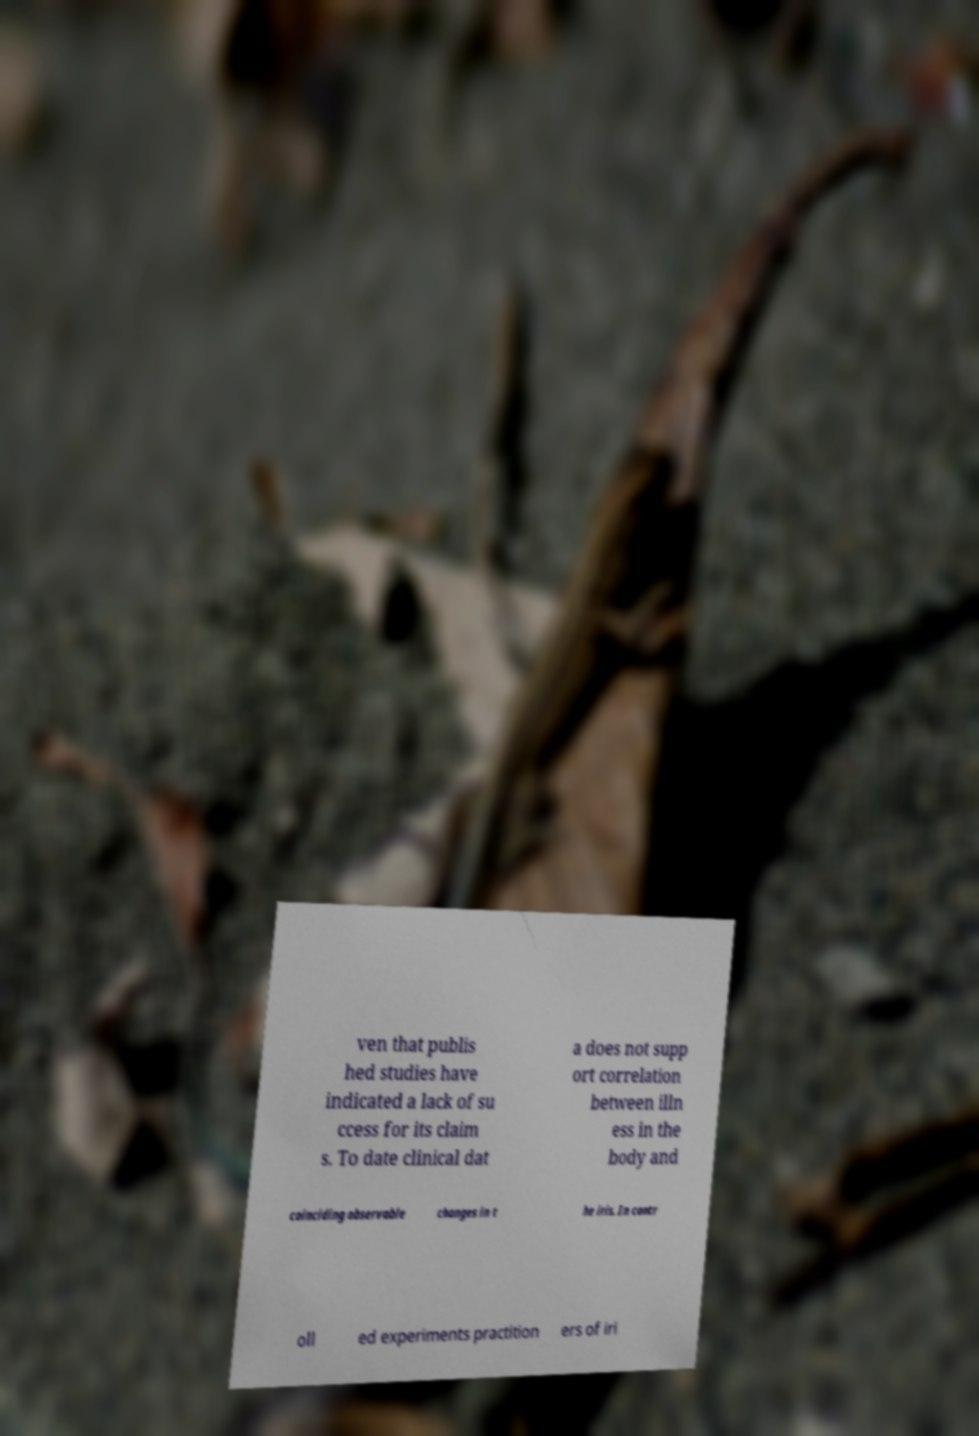I need the written content from this picture converted into text. Can you do that? ven that publis hed studies have indicated a lack of su ccess for its claim s. To date clinical dat a does not supp ort correlation between illn ess in the body and coinciding observable changes in t he iris. In contr oll ed experiments practition ers of iri 